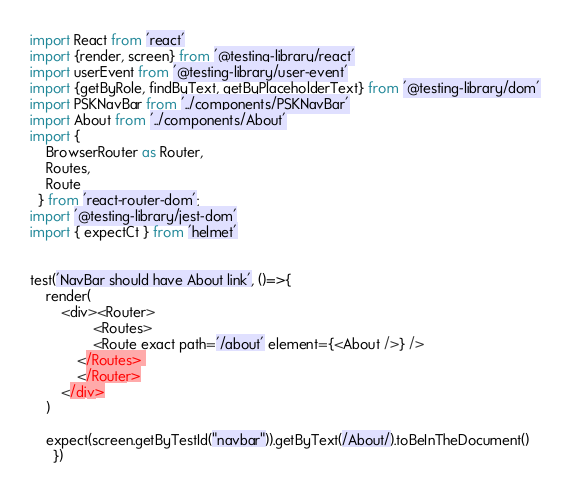Convert code to text. <code><loc_0><loc_0><loc_500><loc_500><_JavaScript_>import React from 'react'
import {render, screen} from '@testing-library/react'
import userEvent from '@testing-library/user-event'
import {getByRole, findByText, getByPlaceholderText} from '@testing-library/dom'
import PSKNavBar from '../components/PSKNavBar' 
import About from '../components/About'
import { 
    BrowserRouter as Router,
    Routes,
    Route
  } from 'react-router-dom'; 
import '@testing-library/jest-dom' 
import { expectCt } from 'helmet'


test('NavBar should have About link', ()=>{
    render(
        <div><Router>
                <Routes>
                <Route exact path='/about' element={<About />} /> 
            </Routes> 
            </Router>
        </div>
    )
    
    expect(screen.getByTestId("navbar")).getByText(/About/).toBeInTheDocument()
      })</code> 